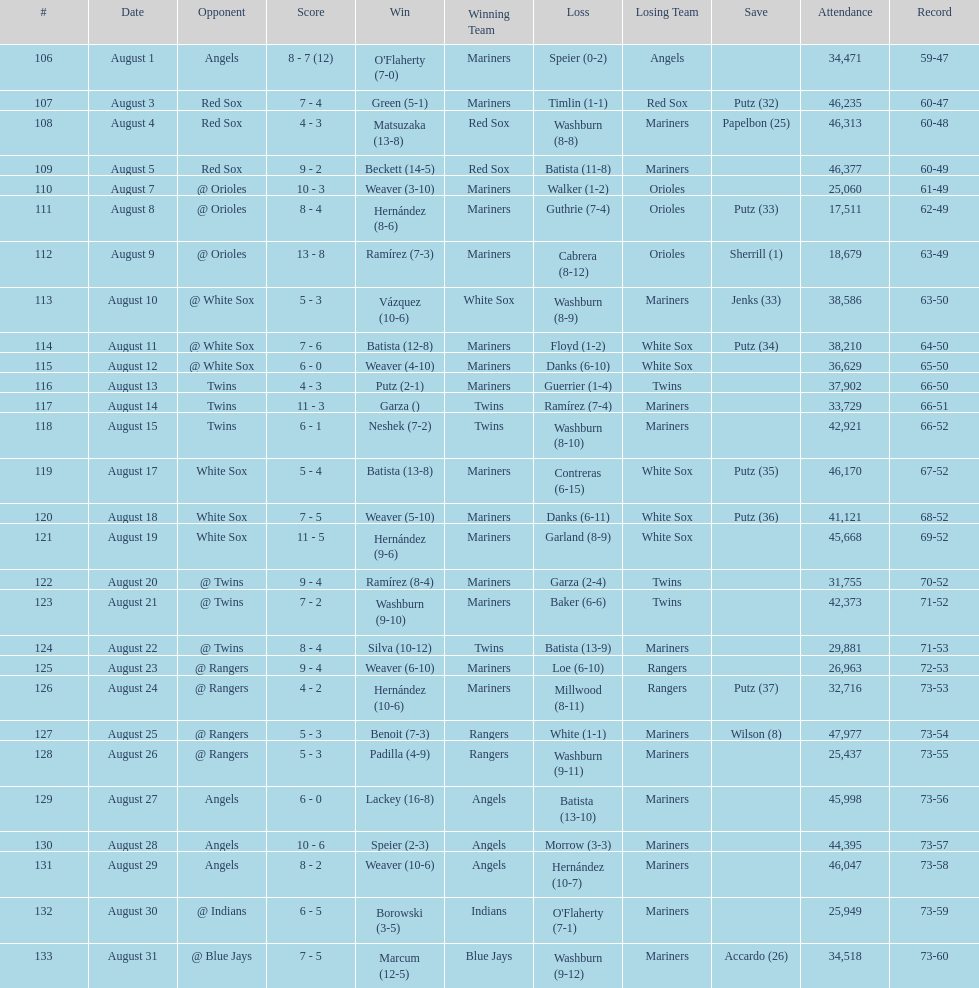Largest run differential 8. 